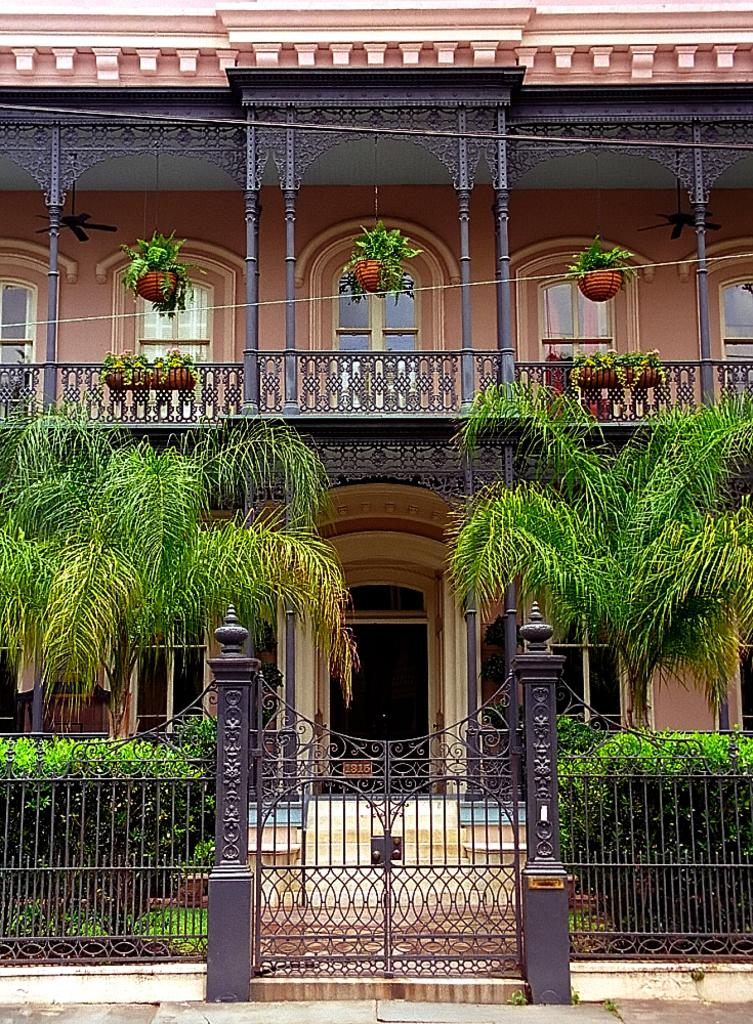What is a feature of the building that allows people to enter or exit? The building has a door. What can be used to let light and air into the building? The building has windows. What is a barrier in front of the building? There is a fence in front of the building. How can people enter the fenced area in front of the building? There is a gate in front of the building. What type of vegetation is present in front of the building? Plants and trees are present in front of the building. What type of tank is visible in front of the building? There is no tank present in front of the building; only a fence, gate, plants, and trees are visible. What addition can be seen on the roof of the building? There is no mention of an addition on the roof of the building in the provided facts. 